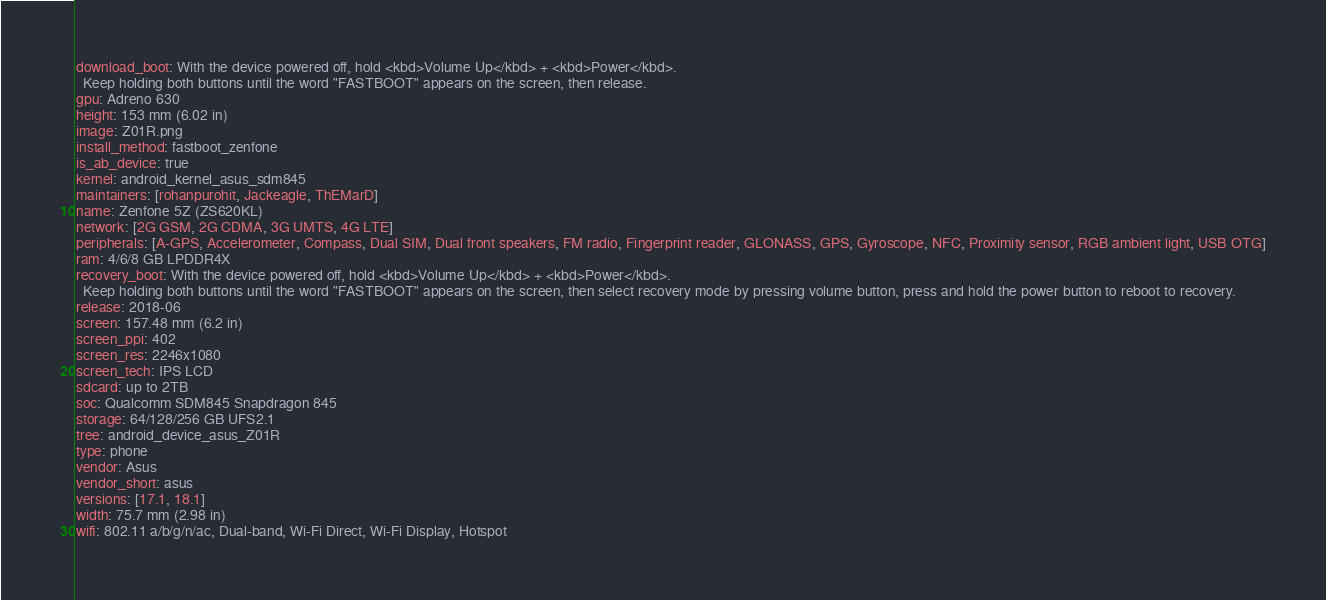<code> <loc_0><loc_0><loc_500><loc_500><_YAML_>download_boot: With the device powered off, hold <kbd>Volume Up</kbd> + <kbd>Power</kbd>.
  Keep holding both buttons until the word "FASTBOOT" appears on the screen, then release.
gpu: Adreno 630
height: 153 mm (6.02 in)
image: Z01R.png
install_method: fastboot_zenfone
is_ab_device: true
kernel: android_kernel_asus_sdm845
maintainers: [rohanpurohit, Jackeagle, ThEMarD]
name: Zenfone 5Z (ZS620KL)
network: [2G GSM, 2G CDMA, 3G UMTS, 4G LTE]
peripherals: [A-GPS, Accelerometer, Compass, Dual SIM, Dual front speakers, FM radio, Fingerprint reader, GLONASS, GPS, Gyroscope, NFC, Proximity sensor, RGB ambient light, USB OTG]
ram: 4/6/8 GB LPDDR4X
recovery_boot: With the device powered off, hold <kbd>Volume Up</kbd> + <kbd>Power</kbd>.
  Keep holding both buttons until the word "FASTBOOT" appears on the screen, then select recovery mode by pressing volume button, press and hold the power button to reboot to recovery.
release: 2018-06
screen: 157.48 mm (6.2 in)
screen_ppi: 402
screen_res: 2246x1080
screen_tech: IPS LCD
sdcard: up to 2TB
soc: Qualcomm SDM845 Snapdragon 845
storage: 64/128/256 GB UFS2.1
tree: android_device_asus_Z01R
type: phone
vendor: Asus
vendor_short: asus
versions: [17.1, 18.1]
width: 75.7 mm (2.98 in)
wifi: 802.11 a/b/g/n/ac, Dual-band, Wi-Fi Direct, Wi-Fi Display, Hotspot
</code> 